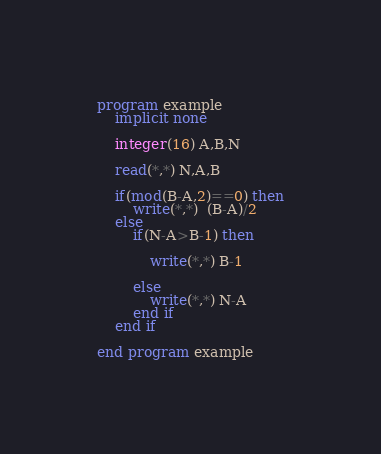Convert code to text. <code><loc_0><loc_0><loc_500><loc_500><_FORTRAN_>program example
	implicit none
    
    integer(16) A,B,N
    
    read(*,*) N,A,B
    
    if(mod(B-A,2)==0) then
    	write(*,*)  (B-A)/2
    else
    	if(N-A>B-1) then
        
        	write(*,*) B-1
        
        else
        	write(*,*) N-A
        end if
    end if

end program example</code> 